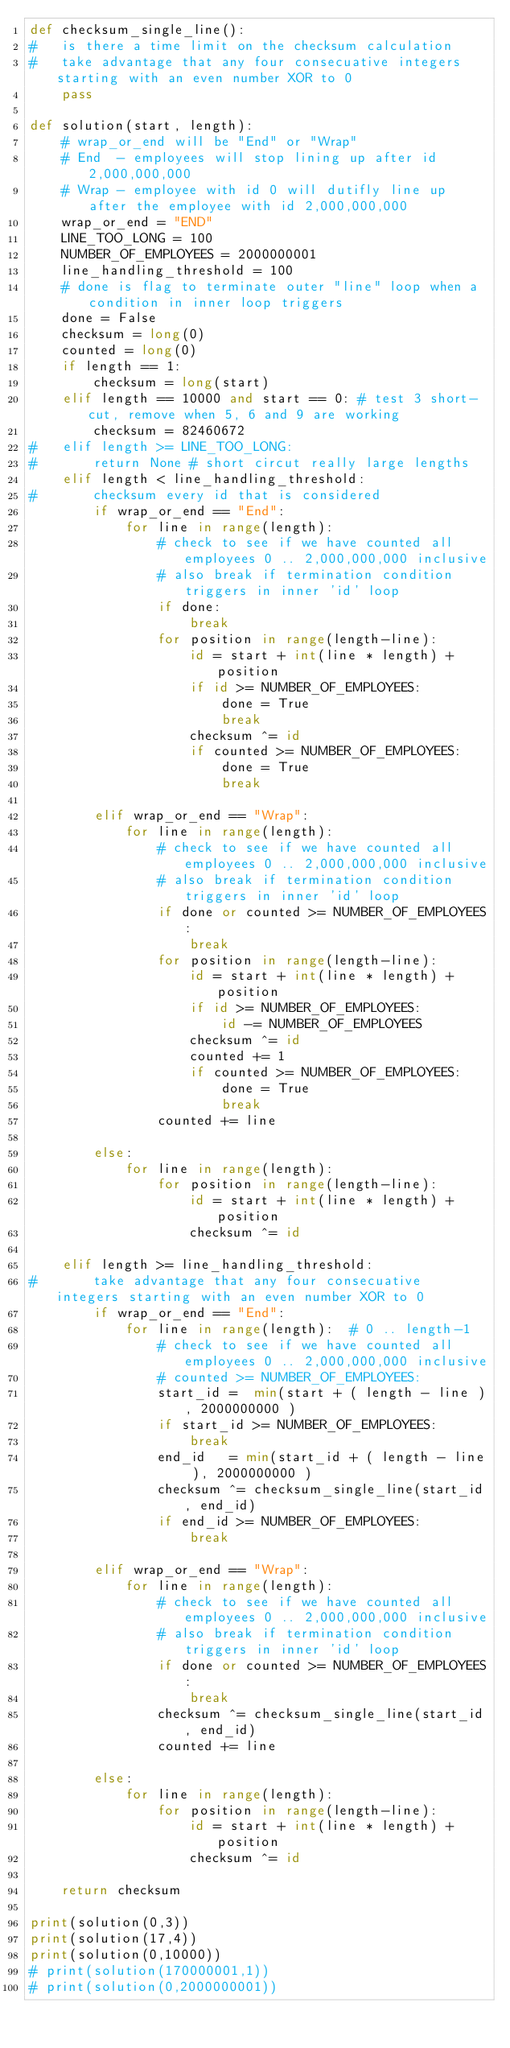<code> <loc_0><loc_0><loc_500><loc_500><_Python_>def checksum_single_line():
#   is there a time limit on the checksum calculation
#   take advantage that any four consecuative integers starting with an even number XOR to 0
    pass
    
def solution(start, length):
    # wrap_or_end will be "End" or "Wrap"
    # End  - employees will stop lining up after id 2,000,000,000
    # Wrap - employee with id 0 will dutifly line up after the employee with id 2,000,000,000
    wrap_or_end = "END"
    LINE_TOO_LONG = 100
    NUMBER_OF_EMPLOYEES = 2000000001
    line_handling_threshold = 100
    # done is flag to terminate outer "line" loop when a condition in inner loop triggers
    done = False
    checksum = long(0)
    counted = long(0)
    if length == 1:
        checksum = long(start)
    elif length == 10000 and start == 0: # test 3 short-cut, remove when 5, 6 and 9 are working
        checksum = 82460672
#   elif length >= LINE_TOO_LONG:
#       return None # short circut really large lengths
    elif length < line_handling_threshold:
#       checksum every id that is considered
        if wrap_or_end == "End":
            for line in range(length):
                # check to see if we have counted all employees 0 .. 2,000,000,000 inclusive
                # also break if termination condition triggers in inner 'id' loop
                if done:
                    break
                for position in range(length-line):
                    id = start + int(line * length) + position
                    if id >= NUMBER_OF_EMPLOYEES:
                        done = True
                        break
                    checksum ^= id
                    if counted >= NUMBER_OF_EMPLOYEES:
                        done = True
                        break

        elif wrap_or_end == "Wrap":
            for line in range(length):
                # check to see if we have counted all employees 0 .. 2,000,000,000 inclusive
                # also break if termination condition triggers in inner 'id' loop
                if done or counted >= NUMBER_OF_EMPLOYEES:
                    break
                for position in range(length-line):
                    id = start + int(line * length) + position
                    if id >= NUMBER_OF_EMPLOYEES:
                        id -= NUMBER_OF_EMPLOYEES
                    checksum ^= id
                    counted += 1
                    if counted >= NUMBER_OF_EMPLOYEES:
                        done = True
                        break
                counted += line

        else:
            for line in range(length):
                for position in range(length-line):
                    id = start + int(line * length) + position
                    checksum ^= id

    elif length >= line_handling_threshold:
#       take advantage that any four consecuative integers starting with an even number XOR to 0
        if wrap_or_end == "End":
            for line in range(length):  # 0 .. length-1
                # check to see if we have counted all employees 0 .. 2,000,000,000 inclusive
                # counted >= NUMBER_OF_EMPLOYEES:
                start_id =  min(start + ( length - line ), 2000000000 )
                if start_id >= NUMBER_OF_EMPLOYEES:
                    break
                end_id   = min(start_id + ( length - line ), 2000000000 )
                checksum ^= checksum_single_line(start_id, end_id)
                if end_id >= NUMBER_OF_EMPLOYEES:
                    break

        elif wrap_or_end == "Wrap":
            for line in range(length):
                # check to see if we have counted all employees 0 .. 2,000,000,000 inclusive
                # also break if termination condition triggers in inner 'id' loop
                if done or counted >= NUMBER_OF_EMPLOYEES:
                    break
                checksum ^= checksum_single_line(start_id, end_id)
                counted += line

        else:
            for line in range(length):
                for position in range(length-line):
                    id = start + int(line * length) + position
                    checksum ^= id

    return checksum

print(solution(0,3))
print(solution(17,4))
print(solution(0,10000))
# print(solution(170000001,1))
# print(solution(0,2000000001))
</code> 